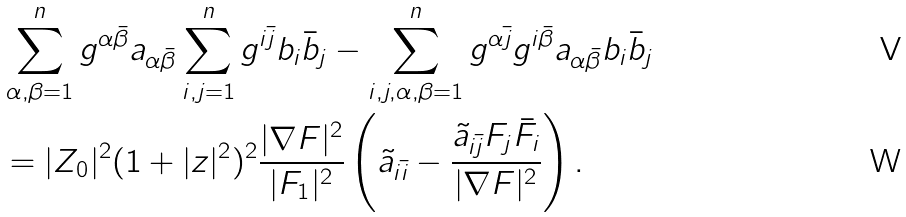<formula> <loc_0><loc_0><loc_500><loc_500>& \sum _ { \alpha , \beta = 1 } ^ { n } g ^ { \alpha \bar { \beta } } a _ { \alpha \bar { \beta } } \sum _ { i , j = 1 } ^ { n } g ^ { i \bar { j } } b _ { i } \bar { b } _ { j } - \sum _ { i , j , \alpha , \beta = 1 } ^ { n } g ^ { \alpha \bar { j } } g ^ { i \bar { \beta } } a _ { \alpha \bar { \beta } } b _ { i } \bar { b } _ { j } \\ & = | Z _ { 0 } | ^ { 2 } ( 1 + | z | ^ { 2 } ) ^ { 2 } \frac { | \nabla F | ^ { 2 } } { | F _ { 1 } | ^ { 2 } } \left ( \tilde { a } _ { i \bar { i } } - \frac { \tilde { a } _ { i \bar { j } } F _ { j } \bar { F } _ { i } } { | \nabla F | ^ { 2 } } \right ) .</formula> 